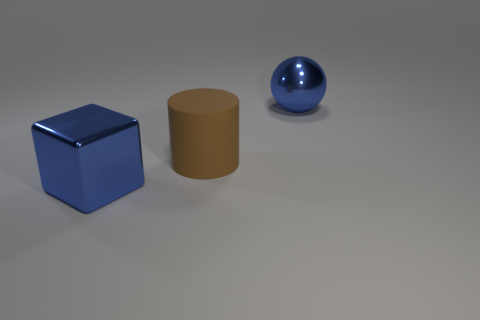Add 3 large shiny cubes. How many objects exist? 6 Subtract all cylinders. How many objects are left? 2 Add 2 large blue balls. How many large blue balls are left? 3 Add 1 brown matte cylinders. How many brown matte cylinders exist? 2 Subtract 1 brown cylinders. How many objects are left? 2 Subtract all red spheres. Subtract all cyan cubes. How many spheres are left? 1 Subtract all large blue balls. Subtract all yellow rubber cylinders. How many objects are left? 2 